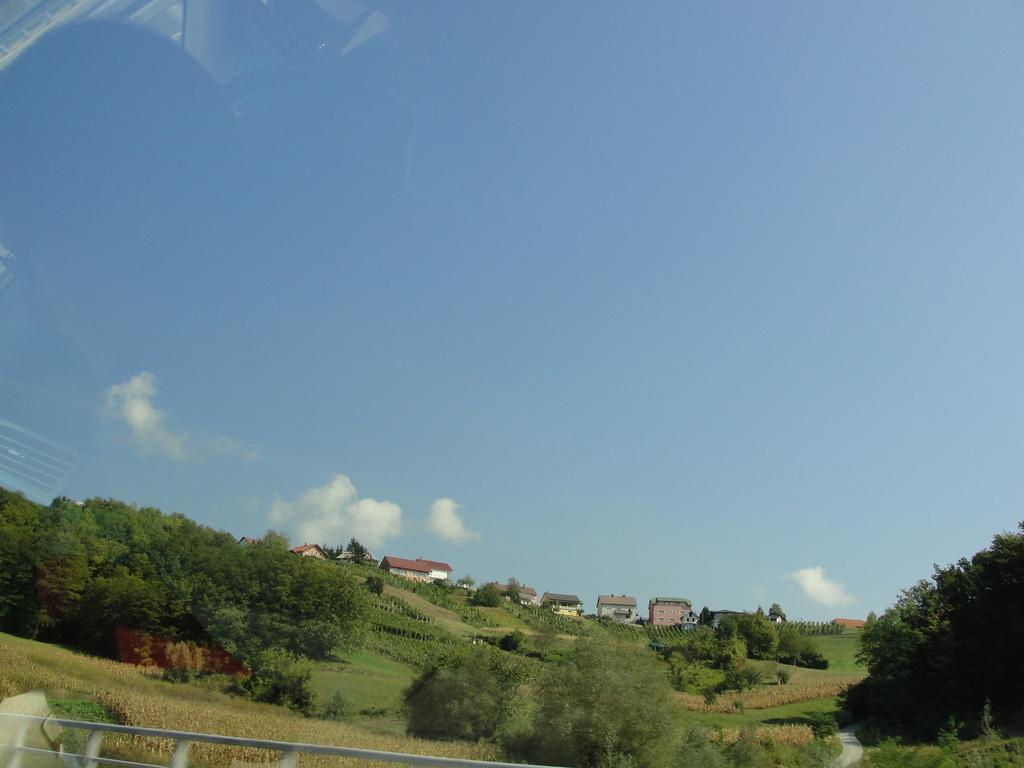What type of vegetation is present in the image? There is grass in the image. What type of structure can be seen in the image? There is a fence in the image. What other natural elements are visible in the image? There are trees in the image. What type of man-made structures can be seen in the image? There are buildings in the image. What is visible in the background of the image? The sky is visible in the background of the image. What can be observed in the sky? There are clouds in the sky. How many hoses are being used by the trucks in the image? There are no trucks or hoses present in the image. What type of home is visible in the image? There is no home visible in the image; it features grass, a fence, trees, buildings, and a sky with clouds. 